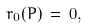Convert formula to latex. <formula><loc_0><loc_0><loc_500><loc_500>r _ { 0 } ( \L P ) \, = \, 0 ,</formula> 